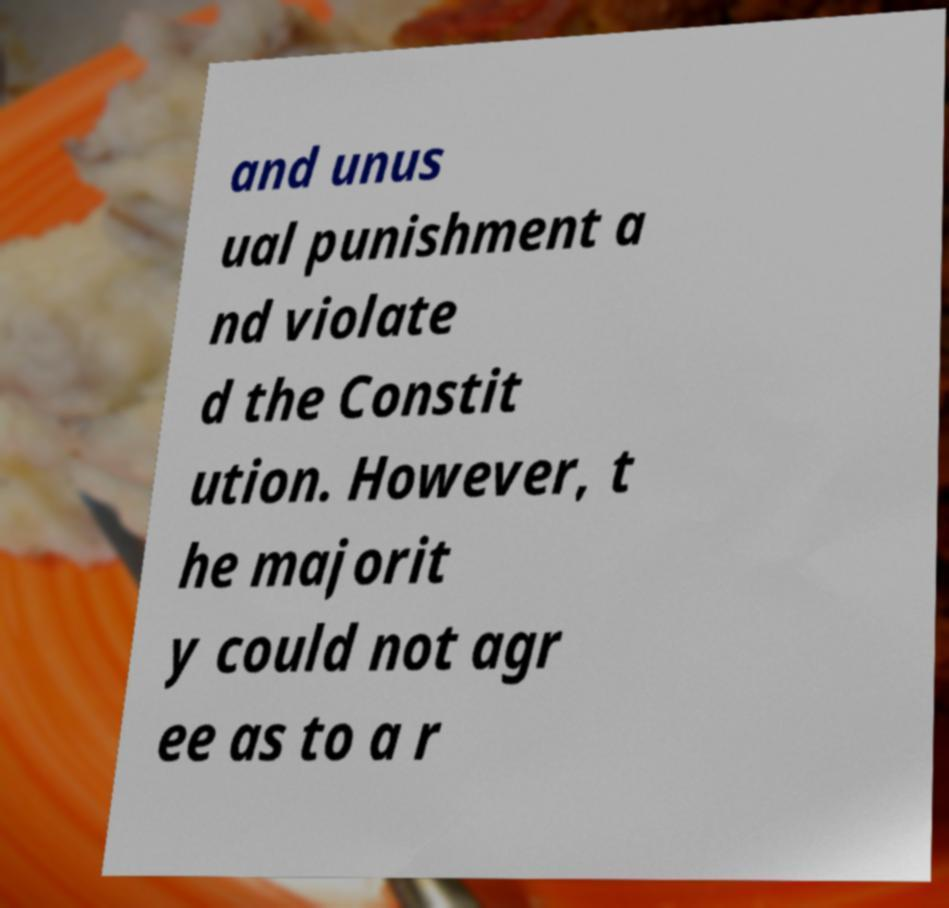For documentation purposes, I need the text within this image transcribed. Could you provide that? and unus ual punishment a nd violate d the Constit ution. However, t he majorit y could not agr ee as to a r 